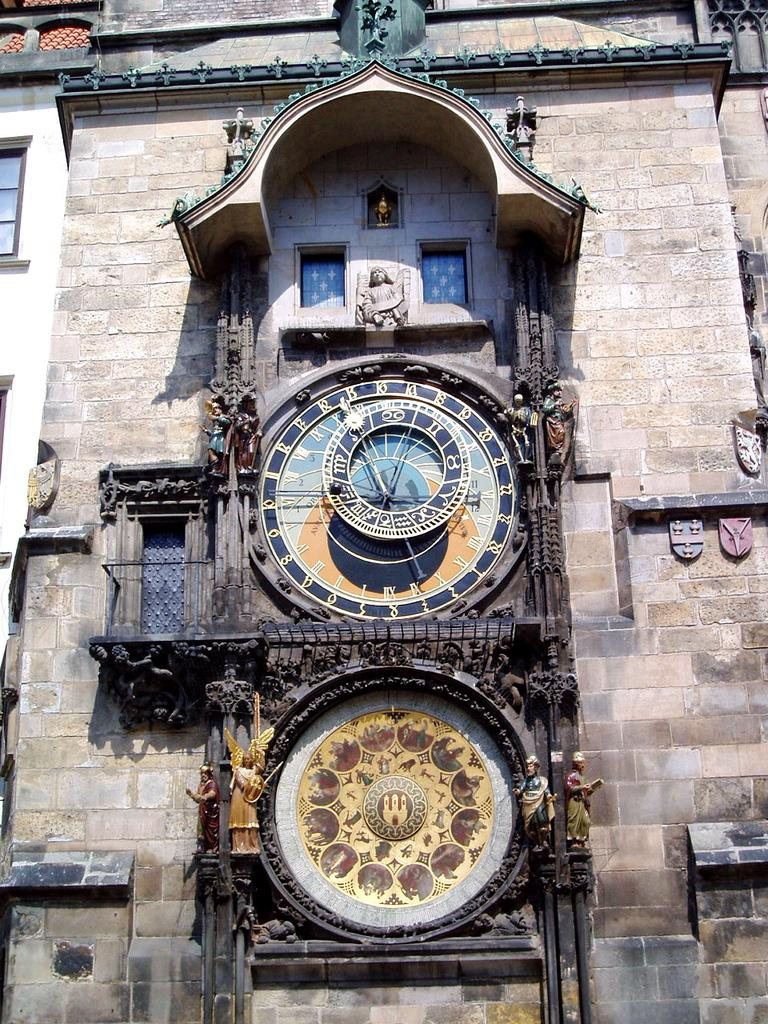What type of structure is visible in the image? There is a building in the image. What feature is present in the middle of the building? The building has a clock in the middle. What is located below the clock? There is an emblem below the clock. What can be seen on either side of the emblem? There are statues on either side of the emblem. What type of holiday is being celebrated in the image? There is no indication of a holiday being celebrated in the image. What tool is being used to wash the statues in the image? There are no tools or washing activities depicted in the image. 